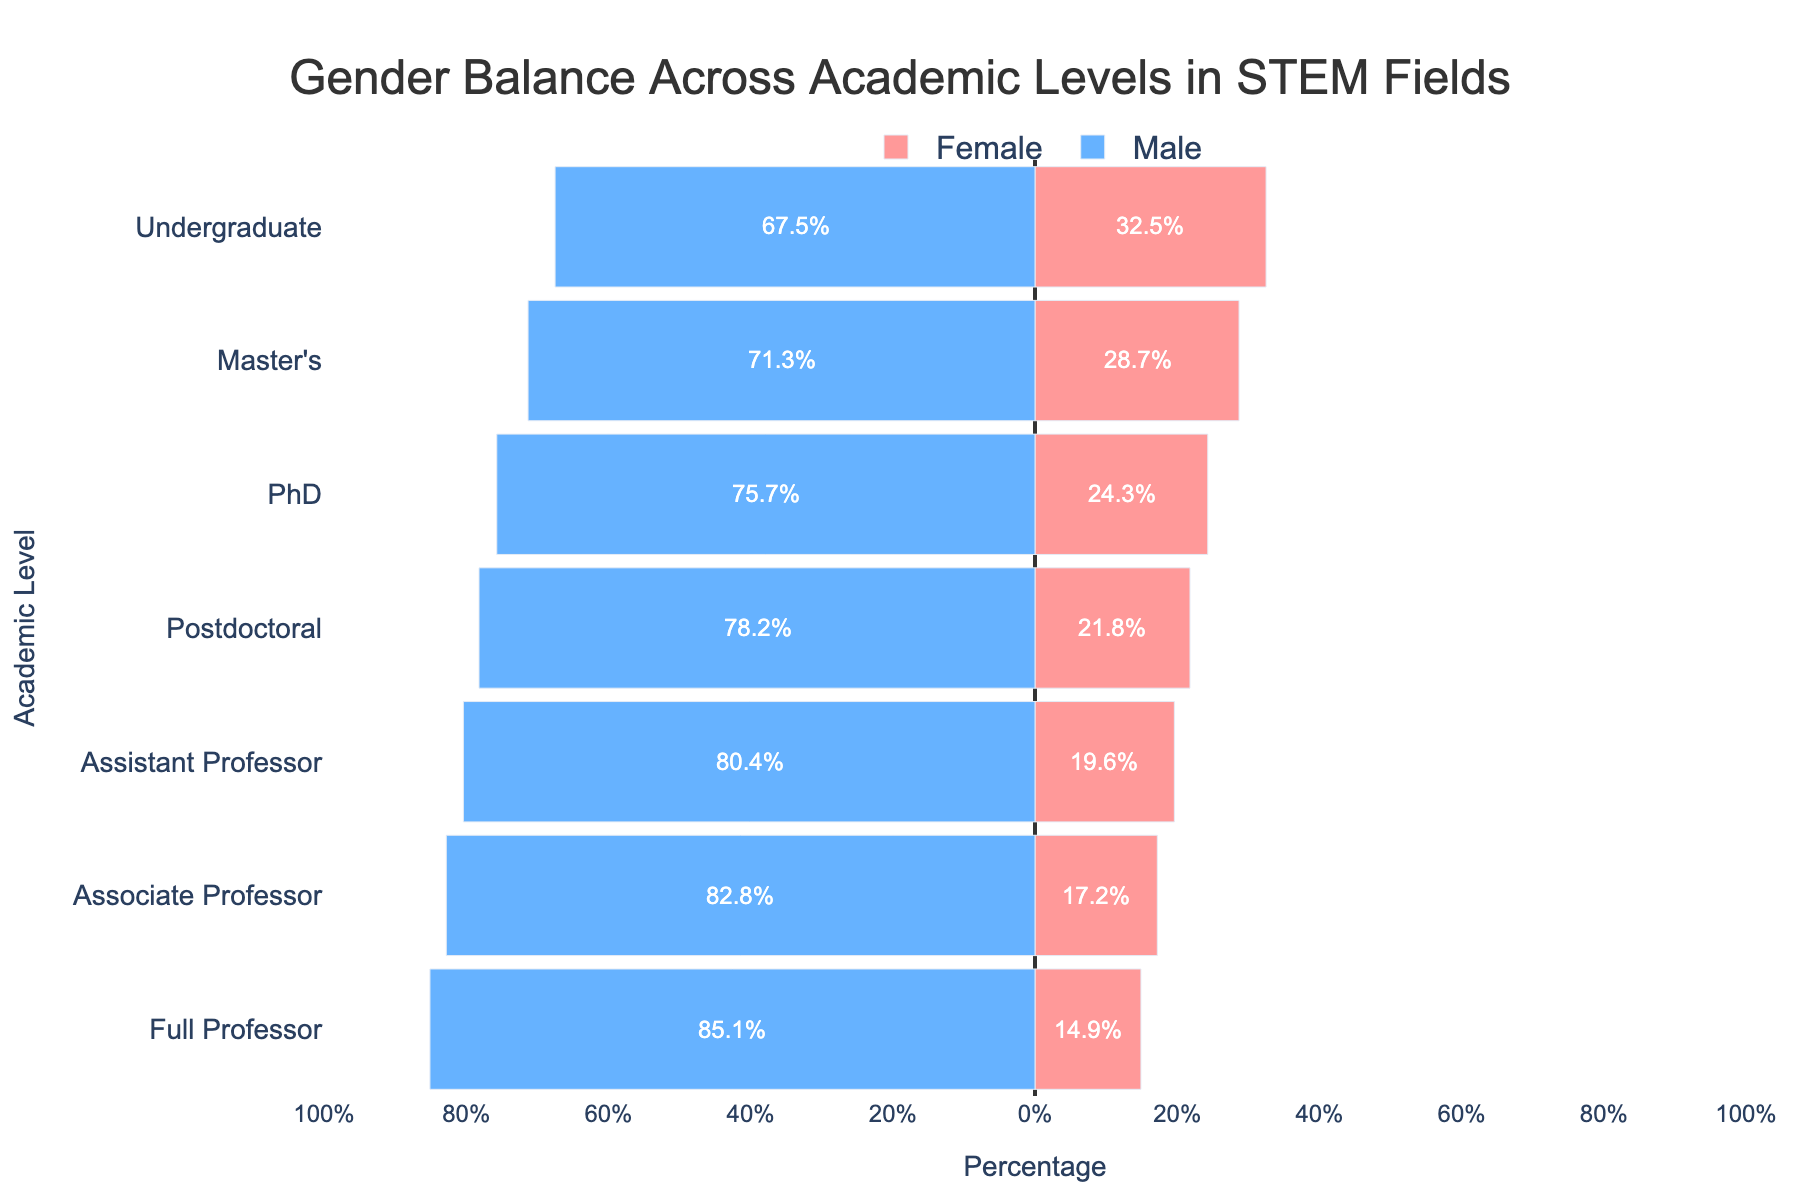How many academic levels are displayed in the figure? There are seven distinct academic levels displayed in the figure: Undergraduate, Master's, PhD, Postdoctoral, Assistant Professor, Associate Professor, and Full Professor.
Answer: 7 Which academic level has the largest gender gap? The largest gender gap can be identified by looking at the academic level with the greatest difference between the percentages of males and females. For 'Full Professor', the gap is 85.1% (Male) - 14.9% (Female) = 70.2%, which is the largest.
Answer: Full Professor What is the total percentage of females at the Master's and PhD levels combined? Add the percentages of females at the Master's and PhD levels: 28.7% (Master's) + 24.3% (PhD).
Answer: 53.0% Which gender predominates at the Undergraduate level in STEM fields according to the figure? The Undergraduate level shows 67.5% Male and 32.5% Female. The predominating gender is therefore male.
Answer: Male By how much does the percentage of females decrease from the Assistant Professor level to the Full Professor level? Subtract the percentage of females at the Full Professor level from that at the Assistant Professor level: 19.6% - 14.9% = 4.7%.
Answer: 4.7% At which academic level is the gender distribution closest to being balanced? The closest balance in gender distribution can be identified by the smallest difference between male and female percentages. The Undergraduate level, with males at 67.5% and females at 32.5%, has the smallest percentage gap (35%).
Answer: Undergraduate What is the gender distribution gap at the Postdoctoral level? The gender distribution gap at the Postdoctoral level is the absolute difference between the percentages of males and females: 78.2% (Male) - 21.8% (Female) = 56.4%.
Answer: 56.4% Is there any academic level where the percentage of males is less than double the percentage of females? By evaluating each academic level, we find that at all levels, the percentage of males is more than double that of females.
Answer: No How does the percentage of males change as one moves up from Undergraduate to Full Professor? To observe the change, list the percentages from Undergraduate to Full Professor: 67.5%, 71.3%, 75.7%, 78.2%, 80.4%, 82.8%, 85.1%. The percentage of males consistently increases at every academic level.
Answer: Increases 